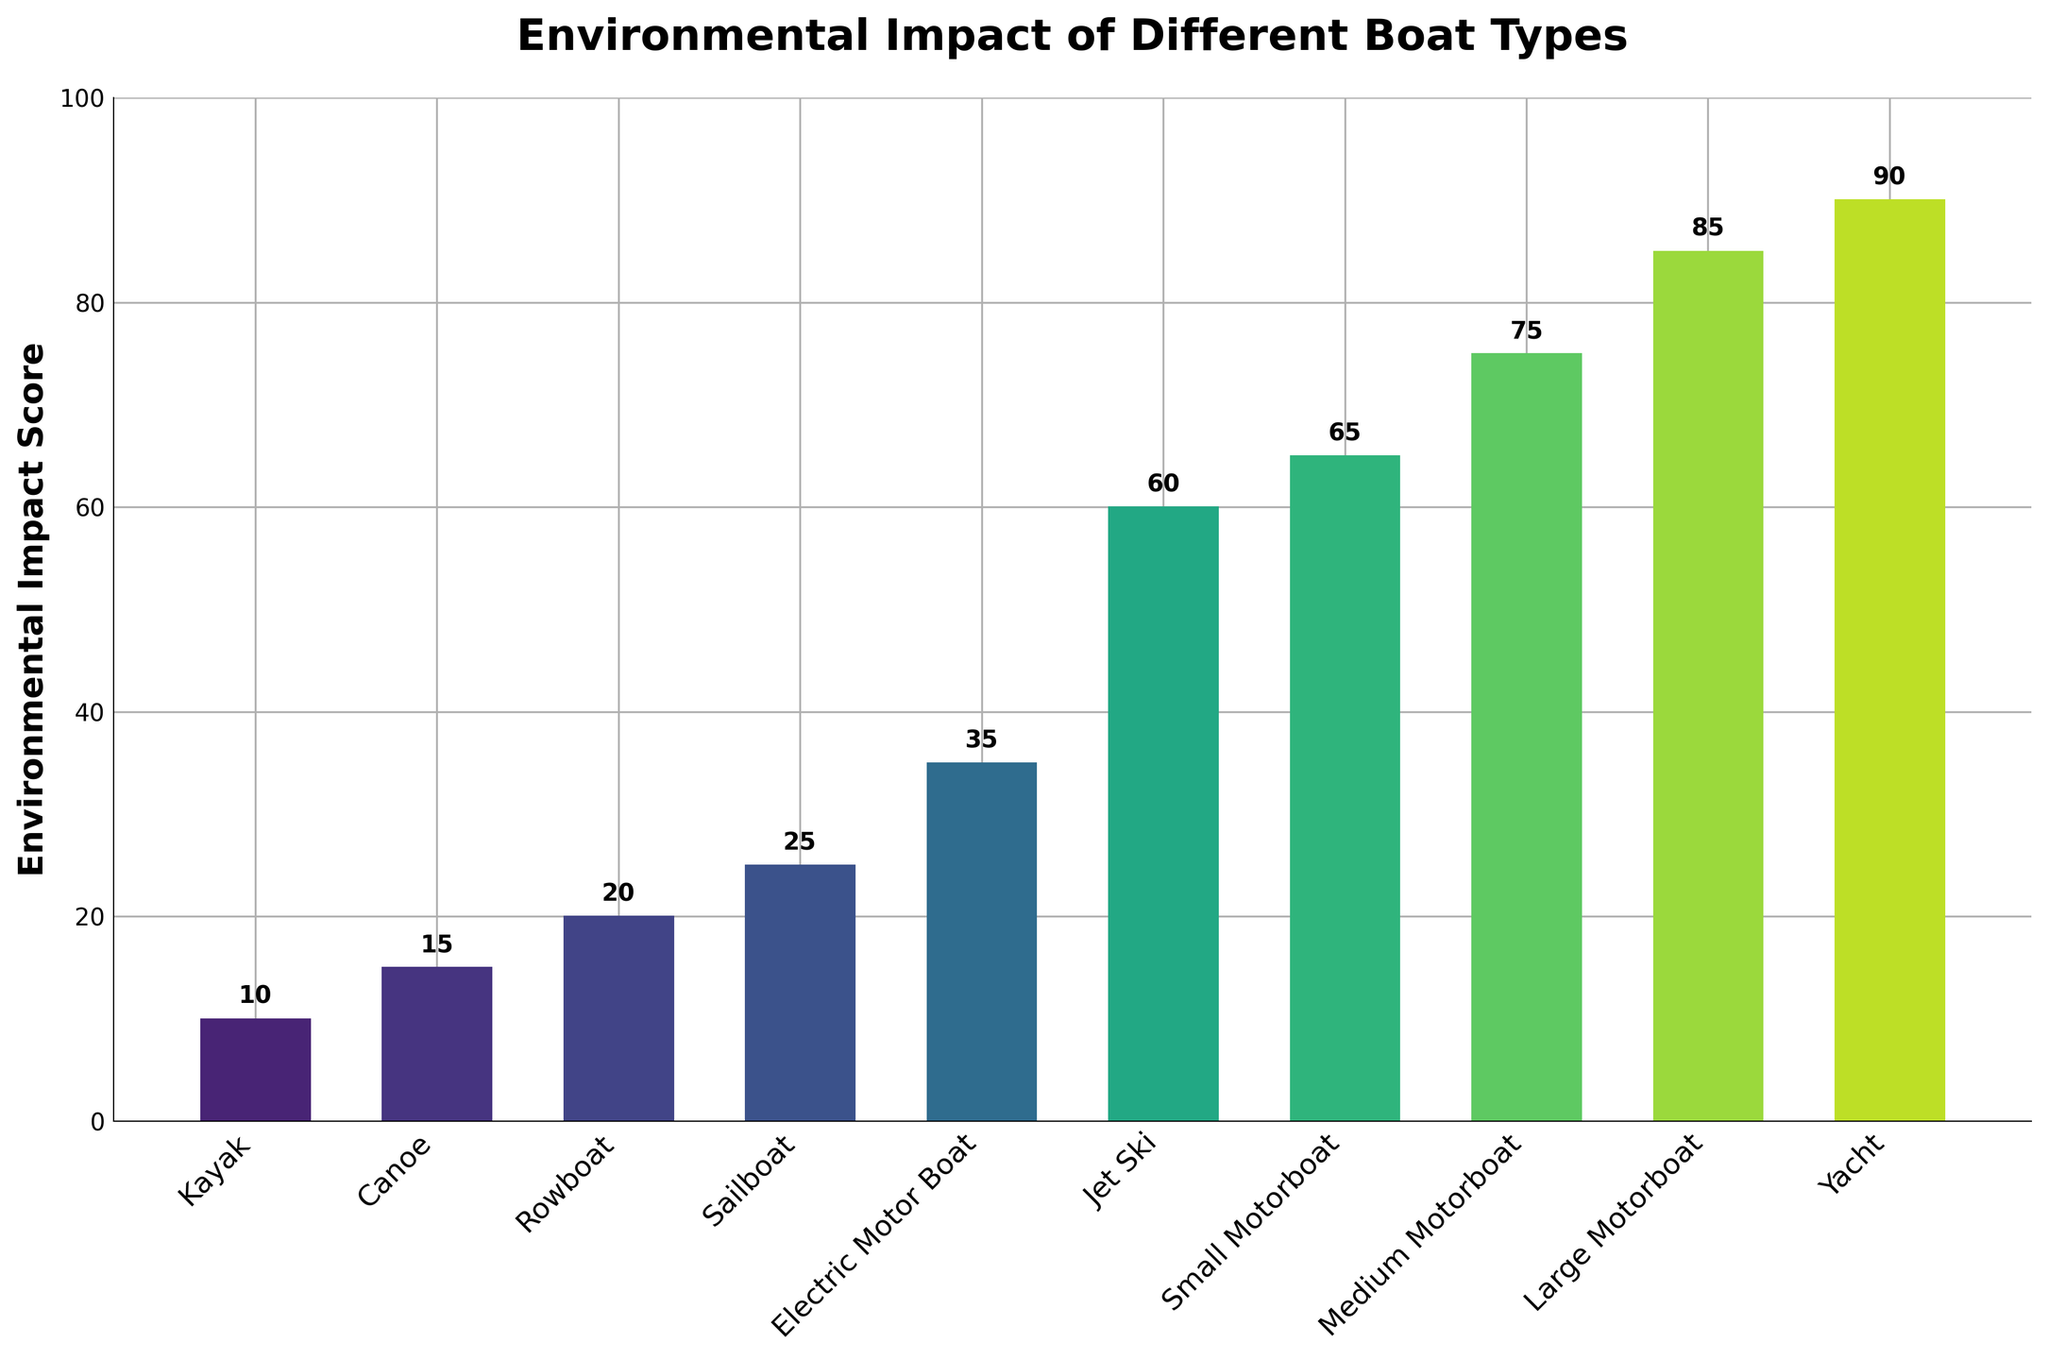What is the boat type with the lowest environmental impact score? The environmental impact scores are displayed as bars, and the shortest bar represents the lowest score. The kayak has the shortest bar and therefore the lowest score of 10.
Answer: Kayak What is the difference in the environmental impact score between a Jet Ski and a Rowboat? Find the scores for both the Jet Ski (60) and the Rowboat (20), then subtract the Rowboat's score from the Jet Ski's score: 60 - 20 = 40.
Answer: 40 Which boat type has an environmental impact score closest to the average score of all boat types? First, calculate the average score: (10+15+20+25+35+60+65+75+85+90)/10 = 48.5. Then, compare how close each value is to 48.5. The Electric Motor Boat with a score of 35 is closest to this average.
Answer: Electric Motor Boat How many boat types have an environmental impact score greater than 50? Count the number of bars whose height is greater than 50. These are Jet Ski (60), Small Motorboat (65), Medium Motorboat (75), Large Motorboat (85), and Yacht (90), so there are 5 boat types.
Answer: 5 What is the median environmental impact score? Arrange the scores in ascending order: 10, 15, 20, 25, 35, 60, 65, 75, 85, 90. Since there are 10 data points, the median is the average of the 5th and 6th scores: (35 + 60) / 2 = 47.5.
Answer: 47.5 Which boat type has the highest environmental impact score? The highest environmental impact score is represented by the tallest bar. The Yacht has the tallest bar with a score of 90.
Answer: Yacht Are there more boat types with an environmental impact score below 50 or above 50? Count the number of scores below 50 (10, 15, 20, 25, 35) which is 5, and above 50 (60, 65, 75, 85, 90) which is also 5. Hence, the counts are equal.
Answer: Equal What is the combined environmental impact score of Kayaks, Canoes, and Rowboats? Add the scores of the Kayak, Canoe, and Rowboat: 10 + 15 + 20 = 45.
Answer: 45 Which has a higher environmental impact score: Electric Motor Boats or Sailboats? Compare the scores of the Electric Motor Boat (35) and the Sailboat (25). The Electric Motor Boat has a higher score.
Answer: Electric Motor Boat What is the range of the environmental impact scores for all boat types? The range is calculated by subtracting the lowest score (Kayak, 10) from the highest score (Yacht, 90): 90 - 10 = 80.
Answer: 80 